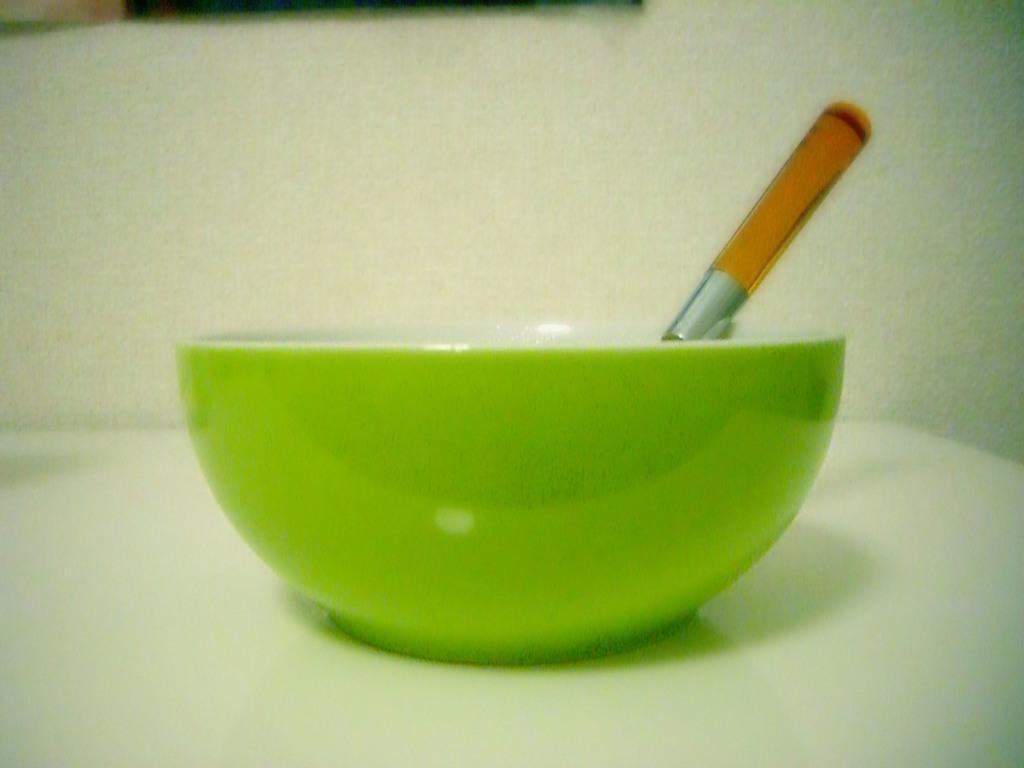Please provide a concise description of this image. The picture consists of a bowl and a spoon placed on the table. On the background it is well. 